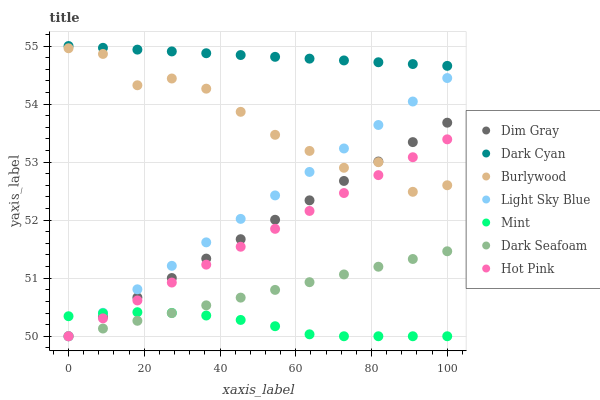Does Mint have the minimum area under the curve?
Answer yes or no. Yes. Does Dark Cyan have the maximum area under the curve?
Answer yes or no. Yes. Does Burlywood have the minimum area under the curve?
Answer yes or no. No. Does Burlywood have the maximum area under the curve?
Answer yes or no. No. Is Dark Seafoam the smoothest?
Answer yes or no. Yes. Is Burlywood the roughest?
Answer yes or no. Yes. Is Hot Pink the smoothest?
Answer yes or no. No. Is Hot Pink the roughest?
Answer yes or no. No. Does Dim Gray have the lowest value?
Answer yes or no. Yes. Does Burlywood have the lowest value?
Answer yes or no. No. Does Dark Cyan have the highest value?
Answer yes or no. Yes. Does Burlywood have the highest value?
Answer yes or no. No. Is Mint less than Dark Cyan?
Answer yes or no. Yes. Is Dark Cyan greater than Light Sky Blue?
Answer yes or no. Yes. Does Dark Seafoam intersect Dim Gray?
Answer yes or no. Yes. Is Dark Seafoam less than Dim Gray?
Answer yes or no. No. Is Dark Seafoam greater than Dim Gray?
Answer yes or no. No. Does Mint intersect Dark Cyan?
Answer yes or no. No. 